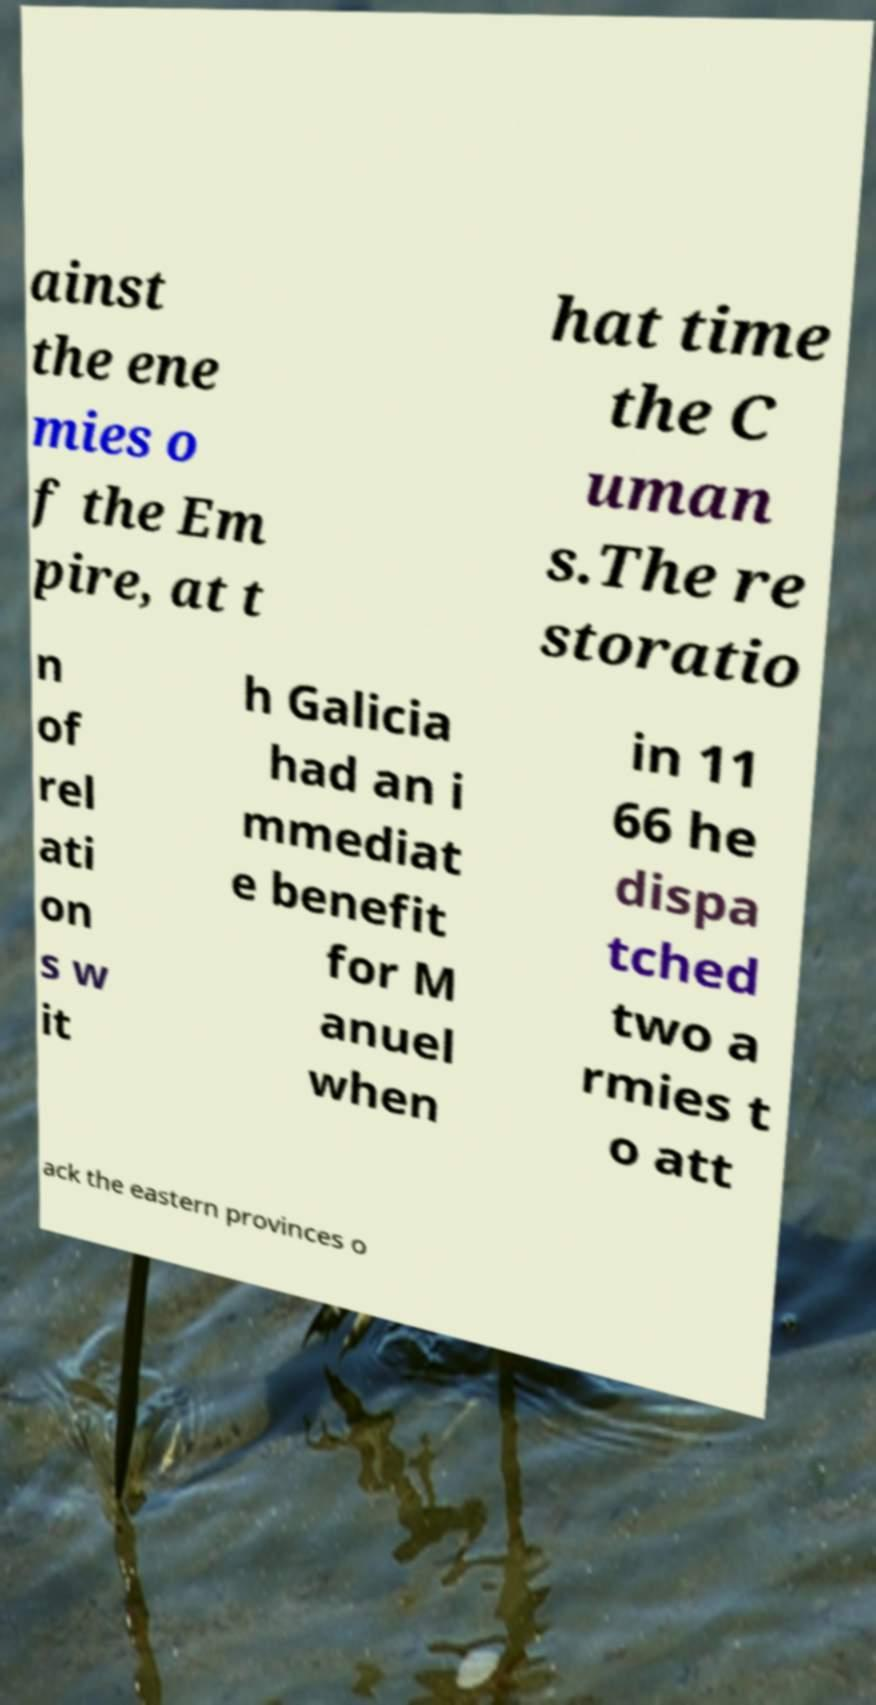I need the written content from this picture converted into text. Can you do that? ainst the ene mies o f the Em pire, at t hat time the C uman s.The re storatio n of rel ati on s w it h Galicia had an i mmediat e benefit for M anuel when in 11 66 he dispa tched two a rmies t o att ack the eastern provinces o 